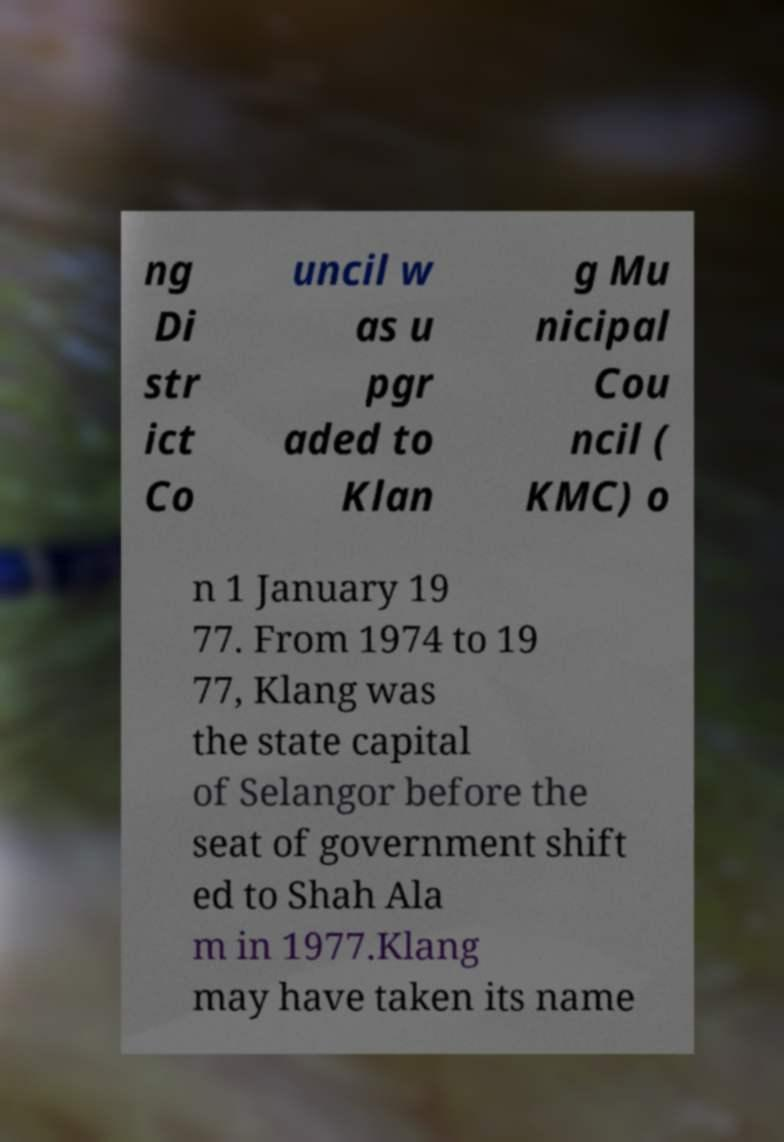Can you read and provide the text displayed in the image?This photo seems to have some interesting text. Can you extract and type it out for me? ng Di str ict Co uncil w as u pgr aded to Klan g Mu nicipal Cou ncil ( KMC) o n 1 January 19 77. From 1974 to 19 77, Klang was the state capital of Selangor before the seat of government shift ed to Shah Ala m in 1977.Klang may have taken its name 